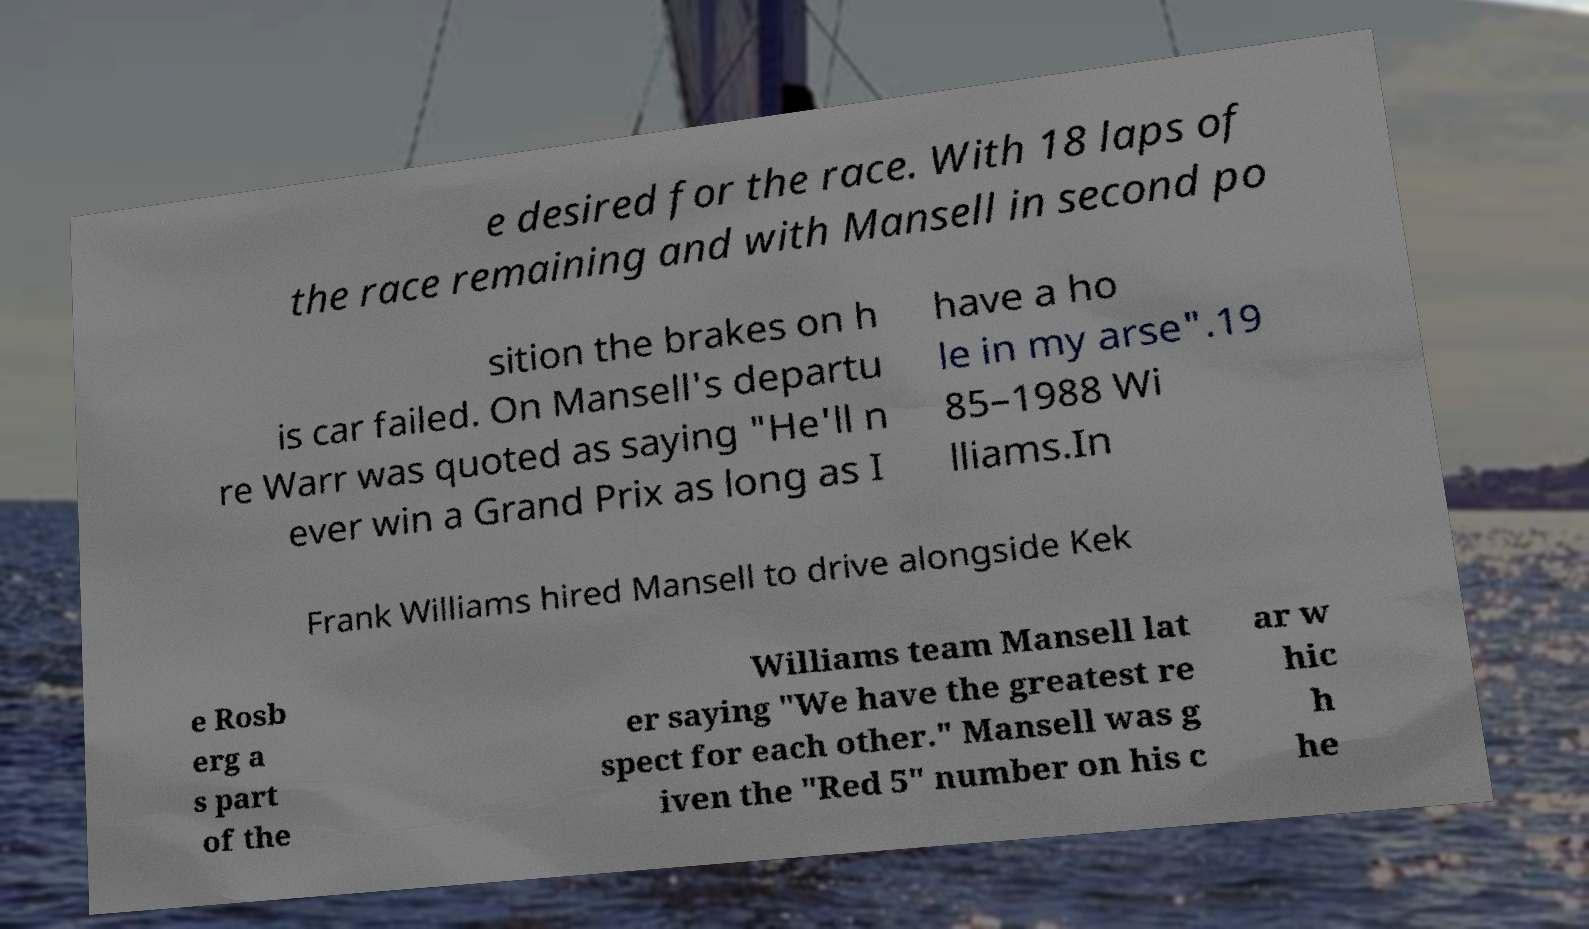Can you accurately transcribe the text from the provided image for me? e desired for the race. With 18 laps of the race remaining and with Mansell in second po sition the brakes on h is car failed. On Mansell's departu re Warr was quoted as saying "He'll n ever win a Grand Prix as long as I have a ho le in my arse".19 85–1988 Wi lliams.In Frank Williams hired Mansell to drive alongside Kek e Rosb erg a s part of the Williams team Mansell lat er saying "We have the greatest re spect for each other." Mansell was g iven the "Red 5" number on his c ar w hic h he 